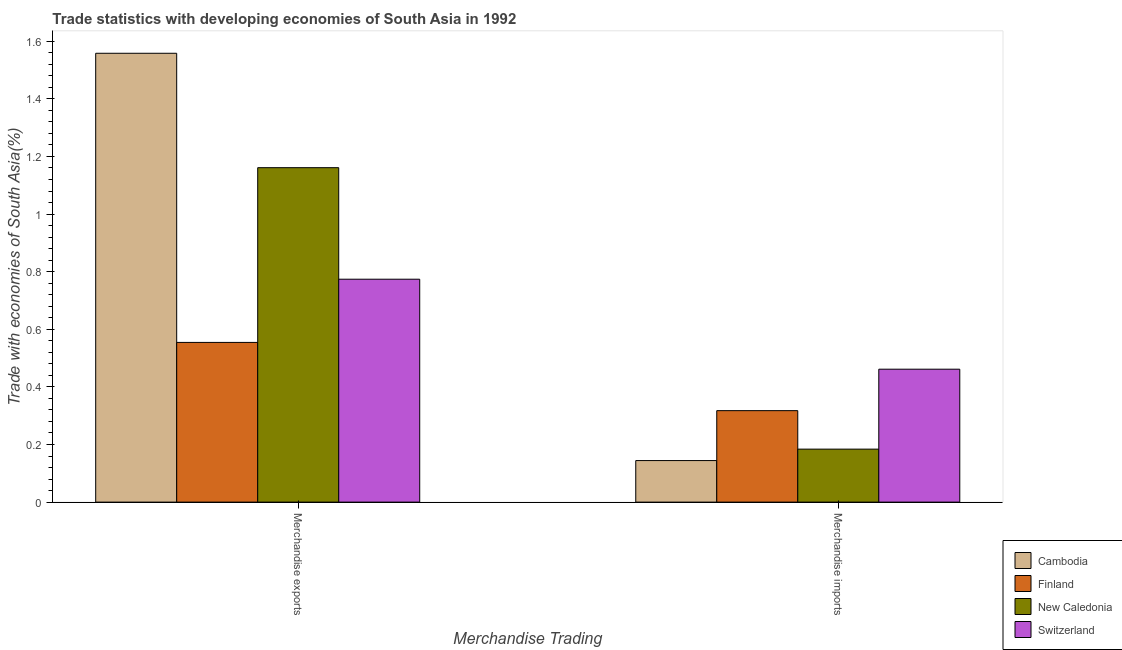How many bars are there on the 1st tick from the right?
Your answer should be very brief. 4. What is the merchandise exports in Finland?
Make the answer very short. 0.55. Across all countries, what is the maximum merchandise exports?
Your answer should be very brief. 1.56. Across all countries, what is the minimum merchandise exports?
Ensure brevity in your answer.  0.55. In which country was the merchandise imports maximum?
Offer a terse response. Switzerland. What is the total merchandise exports in the graph?
Your answer should be compact. 4.05. What is the difference between the merchandise exports in New Caledonia and that in Cambodia?
Your answer should be compact. -0.4. What is the difference between the merchandise exports in New Caledonia and the merchandise imports in Finland?
Give a very brief answer. 0.84. What is the average merchandise imports per country?
Provide a succinct answer. 0.28. What is the difference between the merchandise exports and merchandise imports in Cambodia?
Offer a very short reply. 1.41. In how many countries, is the merchandise exports greater than 1.04 %?
Your answer should be compact. 2. What is the ratio of the merchandise exports in Cambodia to that in Switzerland?
Make the answer very short. 2.01. Is the merchandise exports in Cambodia less than that in New Caledonia?
Give a very brief answer. No. What does the 1st bar from the left in Merchandise imports represents?
Your response must be concise. Cambodia. What does the 4th bar from the right in Merchandise exports represents?
Your answer should be compact. Cambodia. How many bars are there?
Your answer should be compact. 8. Are the values on the major ticks of Y-axis written in scientific E-notation?
Ensure brevity in your answer.  No. Does the graph contain grids?
Provide a succinct answer. No. How many legend labels are there?
Your answer should be compact. 4. How are the legend labels stacked?
Provide a succinct answer. Vertical. What is the title of the graph?
Offer a very short reply. Trade statistics with developing economies of South Asia in 1992. What is the label or title of the X-axis?
Keep it short and to the point. Merchandise Trading. What is the label or title of the Y-axis?
Offer a terse response. Trade with economies of South Asia(%). What is the Trade with economies of South Asia(%) in Cambodia in Merchandise exports?
Your response must be concise. 1.56. What is the Trade with economies of South Asia(%) in Finland in Merchandise exports?
Keep it short and to the point. 0.55. What is the Trade with economies of South Asia(%) in New Caledonia in Merchandise exports?
Your answer should be very brief. 1.16. What is the Trade with economies of South Asia(%) of Switzerland in Merchandise exports?
Make the answer very short. 0.77. What is the Trade with economies of South Asia(%) in Cambodia in Merchandise imports?
Offer a terse response. 0.14. What is the Trade with economies of South Asia(%) of Finland in Merchandise imports?
Provide a short and direct response. 0.32. What is the Trade with economies of South Asia(%) of New Caledonia in Merchandise imports?
Ensure brevity in your answer.  0.18. What is the Trade with economies of South Asia(%) of Switzerland in Merchandise imports?
Provide a short and direct response. 0.46. Across all Merchandise Trading, what is the maximum Trade with economies of South Asia(%) of Cambodia?
Make the answer very short. 1.56. Across all Merchandise Trading, what is the maximum Trade with economies of South Asia(%) in Finland?
Make the answer very short. 0.55. Across all Merchandise Trading, what is the maximum Trade with economies of South Asia(%) of New Caledonia?
Your response must be concise. 1.16. Across all Merchandise Trading, what is the maximum Trade with economies of South Asia(%) in Switzerland?
Offer a very short reply. 0.77. Across all Merchandise Trading, what is the minimum Trade with economies of South Asia(%) of Cambodia?
Offer a very short reply. 0.14. Across all Merchandise Trading, what is the minimum Trade with economies of South Asia(%) in Finland?
Your response must be concise. 0.32. Across all Merchandise Trading, what is the minimum Trade with economies of South Asia(%) of New Caledonia?
Provide a short and direct response. 0.18. Across all Merchandise Trading, what is the minimum Trade with economies of South Asia(%) of Switzerland?
Give a very brief answer. 0.46. What is the total Trade with economies of South Asia(%) in Cambodia in the graph?
Your answer should be compact. 1.7. What is the total Trade with economies of South Asia(%) of Finland in the graph?
Provide a short and direct response. 0.87. What is the total Trade with economies of South Asia(%) of New Caledonia in the graph?
Give a very brief answer. 1.34. What is the total Trade with economies of South Asia(%) of Switzerland in the graph?
Ensure brevity in your answer.  1.24. What is the difference between the Trade with economies of South Asia(%) of Cambodia in Merchandise exports and that in Merchandise imports?
Your answer should be very brief. 1.41. What is the difference between the Trade with economies of South Asia(%) of Finland in Merchandise exports and that in Merchandise imports?
Make the answer very short. 0.24. What is the difference between the Trade with economies of South Asia(%) of New Caledonia in Merchandise exports and that in Merchandise imports?
Your answer should be very brief. 0.98. What is the difference between the Trade with economies of South Asia(%) in Switzerland in Merchandise exports and that in Merchandise imports?
Offer a very short reply. 0.31. What is the difference between the Trade with economies of South Asia(%) of Cambodia in Merchandise exports and the Trade with economies of South Asia(%) of Finland in Merchandise imports?
Provide a succinct answer. 1.24. What is the difference between the Trade with economies of South Asia(%) of Cambodia in Merchandise exports and the Trade with economies of South Asia(%) of New Caledonia in Merchandise imports?
Ensure brevity in your answer.  1.37. What is the difference between the Trade with economies of South Asia(%) in Cambodia in Merchandise exports and the Trade with economies of South Asia(%) in Switzerland in Merchandise imports?
Make the answer very short. 1.1. What is the difference between the Trade with economies of South Asia(%) of Finland in Merchandise exports and the Trade with economies of South Asia(%) of New Caledonia in Merchandise imports?
Your answer should be compact. 0.37. What is the difference between the Trade with economies of South Asia(%) of Finland in Merchandise exports and the Trade with economies of South Asia(%) of Switzerland in Merchandise imports?
Provide a succinct answer. 0.09. What is the difference between the Trade with economies of South Asia(%) in New Caledonia in Merchandise exports and the Trade with economies of South Asia(%) in Switzerland in Merchandise imports?
Provide a short and direct response. 0.7. What is the average Trade with economies of South Asia(%) in Cambodia per Merchandise Trading?
Offer a terse response. 0.85. What is the average Trade with economies of South Asia(%) in Finland per Merchandise Trading?
Give a very brief answer. 0.44. What is the average Trade with economies of South Asia(%) in New Caledonia per Merchandise Trading?
Ensure brevity in your answer.  0.67. What is the average Trade with economies of South Asia(%) of Switzerland per Merchandise Trading?
Your answer should be compact. 0.62. What is the difference between the Trade with economies of South Asia(%) in Cambodia and Trade with economies of South Asia(%) in New Caledonia in Merchandise exports?
Your answer should be compact. 0.4. What is the difference between the Trade with economies of South Asia(%) of Cambodia and Trade with economies of South Asia(%) of Switzerland in Merchandise exports?
Your answer should be very brief. 0.78. What is the difference between the Trade with economies of South Asia(%) of Finland and Trade with economies of South Asia(%) of New Caledonia in Merchandise exports?
Your answer should be very brief. -0.61. What is the difference between the Trade with economies of South Asia(%) in Finland and Trade with economies of South Asia(%) in Switzerland in Merchandise exports?
Make the answer very short. -0.22. What is the difference between the Trade with economies of South Asia(%) in New Caledonia and Trade with economies of South Asia(%) in Switzerland in Merchandise exports?
Provide a short and direct response. 0.39. What is the difference between the Trade with economies of South Asia(%) of Cambodia and Trade with economies of South Asia(%) of Finland in Merchandise imports?
Provide a short and direct response. -0.17. What is the difference between the Trade with economies of South Asia(%) of Cambodia and Trade with economies of South Asia(%) of New Caledonia in Merchandise imports?
Provide a succinct answer. -0.04. What is the difference between the Trade with economies of South Asia(%) of Cambodia and Trade with economies of South Asia(%) of Switzerland in Merchandise imports?
Provide a short and direct response. -0.32. What is the difference between the Trade with economies of South Asia(%) of Finland and Trade with economies of South Asia(%) of New Caledonia in Merchandise imports?
Offer a very short reply. 0.13. What is the difference between the Trade with economies of South Asia(%) of Finland and Trade with economies of South Asia(%) of Switzerland in Merchandise imports?
Your answer should be compact. -0.14. What is the difference between the Trade with economies of South Asia(%) of New Caledonia and Trade with economies of South Asia(%) of Switzerland in Merchandise imports?
Provide a succinct answer. -0.28. What is the ratio of the Trade with economies of South Asia(%) in Cambodia in Merchandise exports to that in Merchandise imports?
Your response must be concise. 10.8. What is the ratio of the Trade with economies of South Asia(%) of Finland in Merchandise exports to that in Merchandise imports?
Your answer should be compact. 1.75. What is the ratio of the Trade with economies of South Asia(%) in New Caledonia in Merchandise exports to that in Merchandise imports?
Make the answer very short. 6.31. What is the ratio of the Trade with economies of South Asia(%) in Switzerland in Merchandise exports to that in Merchandise imports?
Make the answer very short. 1.68. What is the difference between the highest and the second highest Trade with economies of South Asia(%) in Cambodia?
Keep it short and to the point. 1.41. What is the difference between the highest and the second highest Trade with economies of South Asia(%) in Finland?
Your answer should be very brief. 0.24. What is the difference between the highest and the second highest Trade with economies of South Asia(%) of New Caledonia?
Provide a succinct answer. 0.98. What is the difference between the highest and the second highest Trade with economies of South Asia(%) of Switzerland?
Provide a succinct answer. 0.31. What is the difference between the highest and the lowest Trade with economies of South Asia(%) in Cambodia?
Offer a very short reply. 1.41. What is the difference between the highest and the lowest Trade with economies of South Asia(%) of Finland?
Your answer should be very brief. 0.24. What is the difference between the highest and the lowest Trade with economies of South Asia(%) in New Caledonia?
Offer a terse response. 0.98. What is the difference between the highest and the lowest Trade with economies of South Asia(%) in Switzerland?
Make the answer very short. 0.31. 